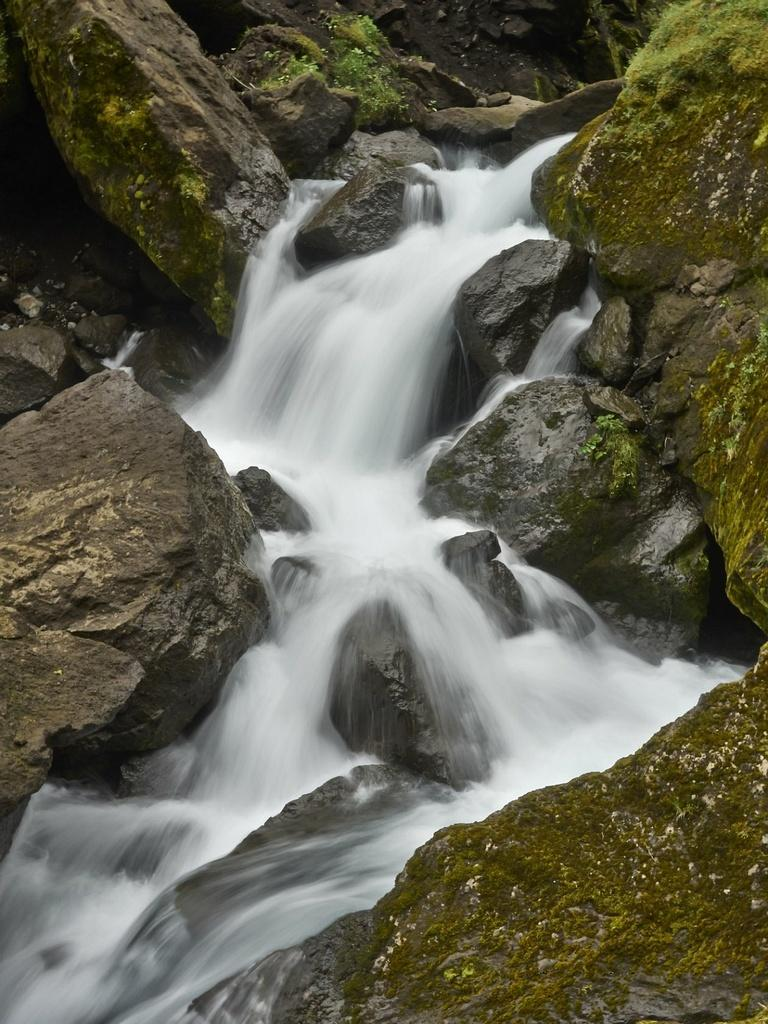What type of natural elements can be seen in the image? There are stones and water visible in the image. What type of vegetation is present in the image? There is green color grass in the image. What time does the clock show in the image? There is no clock present in the image. How many houses can be seen in the image? There are no houses visible in the image. 